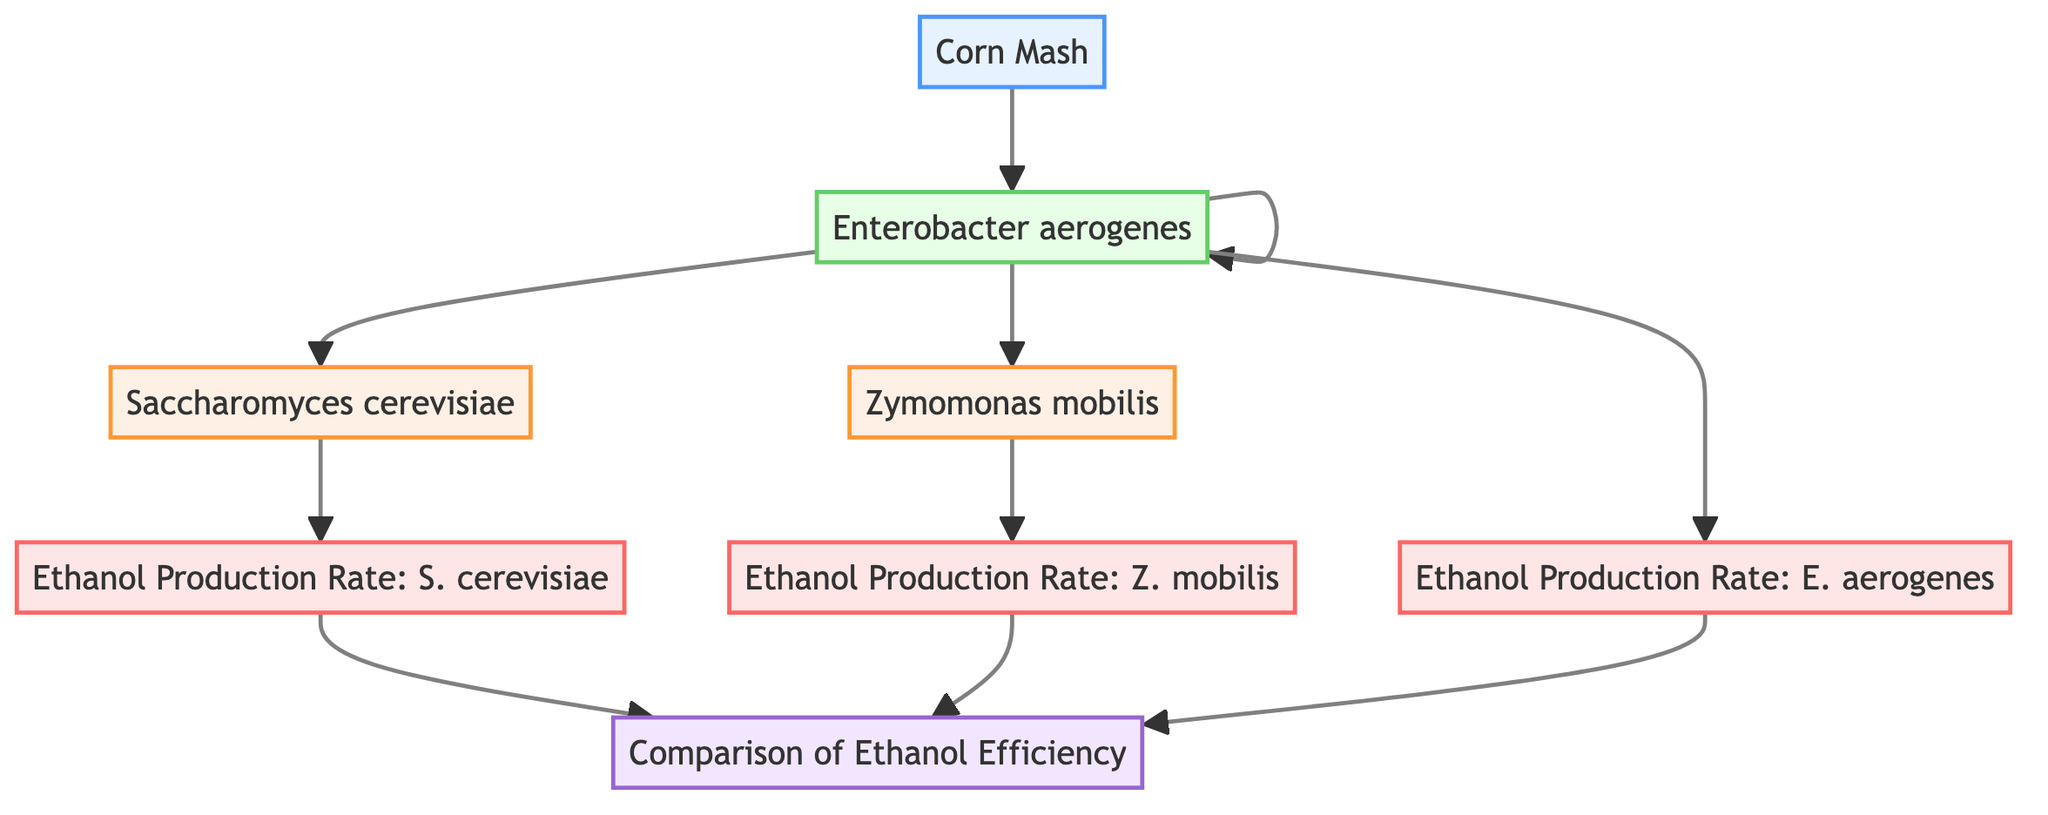What is the input material for the fermentation process? The diagram clearly indicates that "Corn Mash" is the input material, as it is labeled under the "Input" category.
Answer: Corn Mash Which microorganism is represented as Saccharomyces cerevisiae? Referring to the diagram, "Saccharomyces cerevisiae" is listed as one of the bacterial strains, specifically labeled under "Microorganism."
Answer: Saccharomyces cerevisiae How many bacterial strains are involved in this diagram? By counting the nodes categorized as "Microorganism," we find three, which are Saccharomyces cerevisiae, Zymomonas mobilis, and Enterobacter aerogenes.
Answer: 3 What is the output of the fermentation process using Zymomonas mobilis? The output node labeled "Ethanol Production Rate: Z. mobilis" specifies the conversion rate for this particular microorganism, indicating it is the output of interest here.
Answer: Ethanol Production Rate: Z. mobilis Which step follows the enzyme activity in the fermentation process? In the flow of the diagram, after "Enzyme Activity," the next entities are the three bacterial strains, indicating they all follow enzyme activity.
Answer: Saccharomyces cerevisiae, Zymomonas mobilis, Enterobacter aerogenes What type of analysis is performed after calculating the ethanol production rates? At the end of the flowchart, the node "Comparison of Ethanol Efficiency" shows that it encapsulates the evaluation process conducted after deriving the production rates.
Answer: Comparison of Ethanol Efficiency Which bacterial strain is known for high ethanol yields? The description of "Zymomonas mobilis" explicitly indicates that it is known for high ethanol yields, distinguishing it from other strains in the diagram.
Answer: Zymomonas mobilis What is the relationship between Corn Mash and Enzyme Activity? The diagram illustrates that "Corn Mash" is the input that leads into "Enzyme Activity," establishing a direct cause-and-effect relationship between them.
Answer: Corn Mash → Enzyme Activity Which outputs are compared in the analysis of ethanol efficiency? The outputs to be compared in the analysis are the production rates of all three bacterial strains: Saccharomyces cerevisiae, Zymomonas mobilis, and Enterobacter aerogenes.
Answer: Ethanol Production Rate: S. cerevisiae, Ethanol Production Rate: Z. mobilis, Ethanol Production Rate: E. aerogenes 